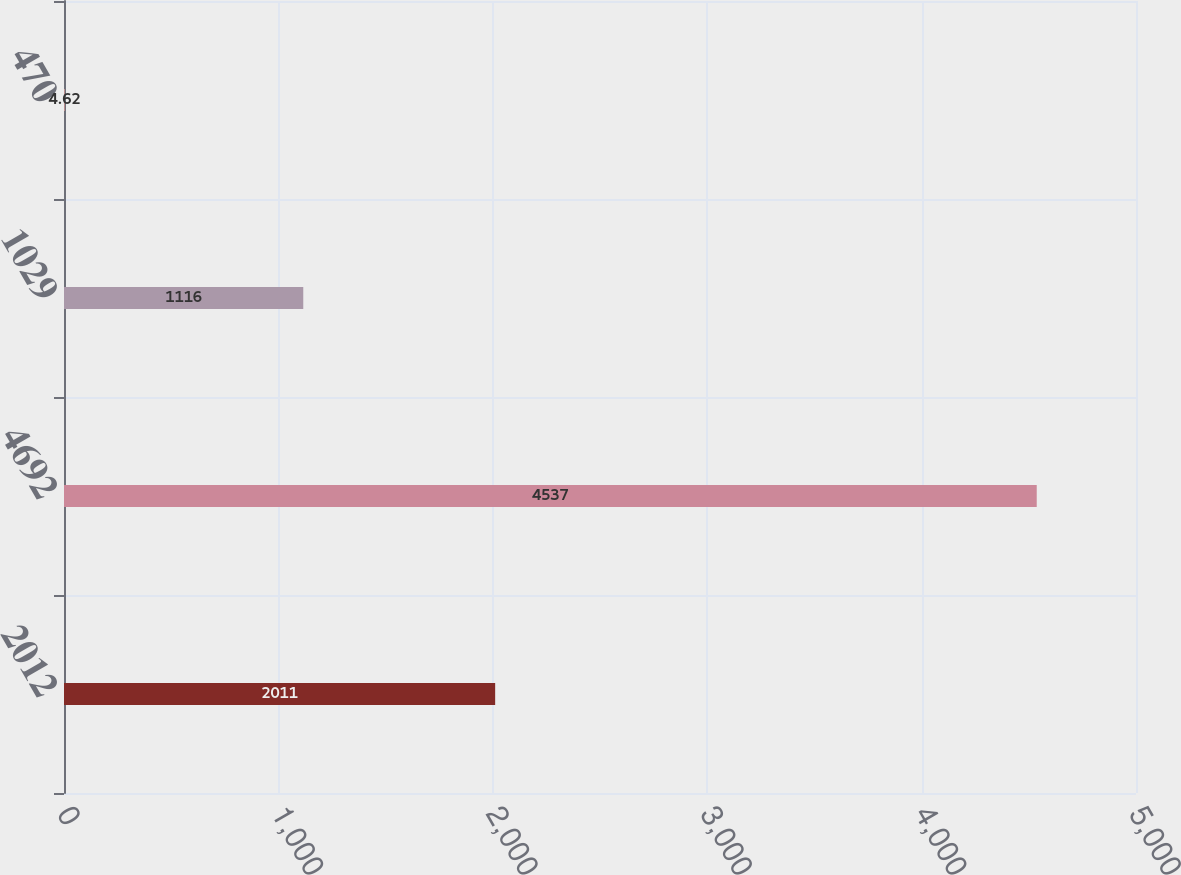Convert chart. <chart><loc_0><loc_0><loc_500><loc_500><bar_chart><fcel>2012<fcel>4692<fcel>1029<fcel>470<nl><fcel>2011<fcel>4537<fcel>1116<fcel>4.62<nl></chart> 